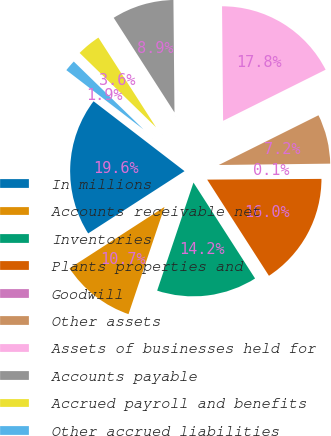Convert chart to OTSL. <chart><loc_0><loc_0><loc_500><loc_500><pie_chart><fcel>In millions<fcel>Accounts receivable net<fcel>Inventories<fcel>Plants properties and<fcel>Goodwill<fcel>Other assets<fcel>Assets of businesses held for<fcel>Accounts payable<fcel>Accrued payroll and benefits<fcel>Other accrued liabilities<nl><fcel>19.56%<fcel>10.71%<fcel>14.25%<fcel>16.02%<fcel>0.09%<fcel>7.17%<fcel>17.79%<fcel>8.94%<fcel>3.63%<fcel>1.86%<nl></chart> 